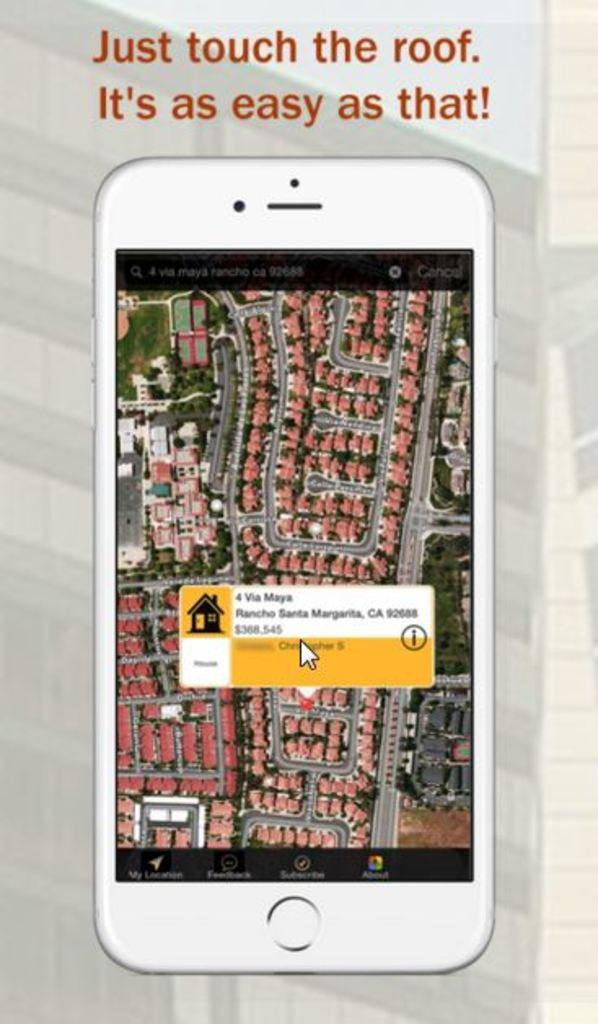<image>
Provide a brief description of the given image. An ad shows an ap on a phone where you just touch the roof to get information. 